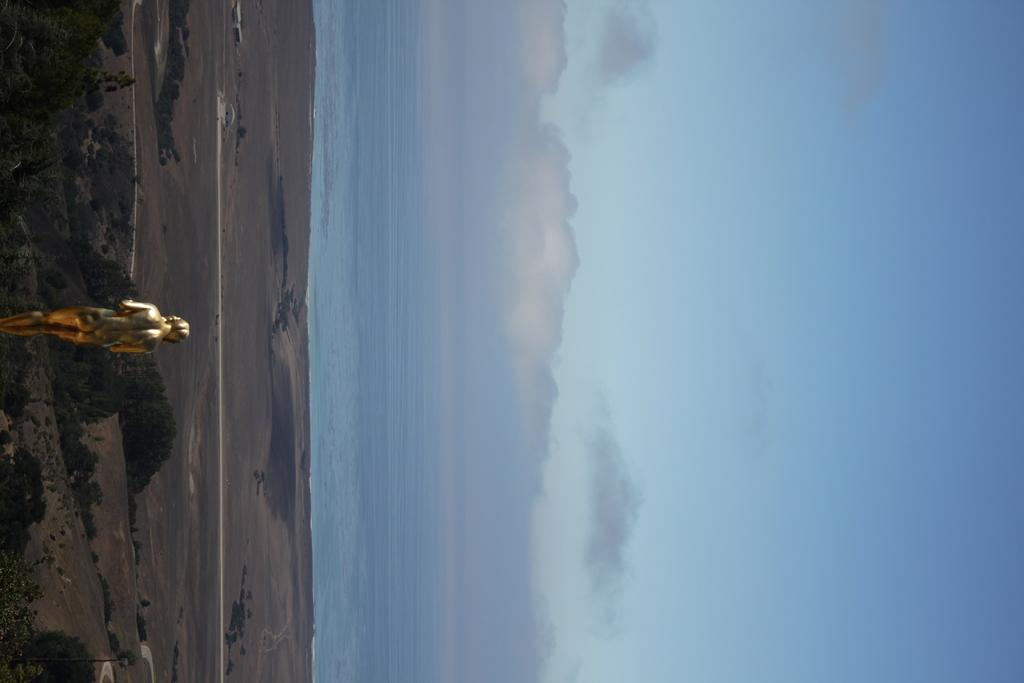What is the main subject in the image? There is a statue in the image. What can be seen beneath the statue? The ground is visible in the image. What type of natural elements are present in the image? There are trees and water visible in the image. What is visible above the statue? The sky is visible in the image, and clouds are present in the sky. How many stories does the island have in the image? There is no island present in the image, so it is not possible to determine the number of stories. 